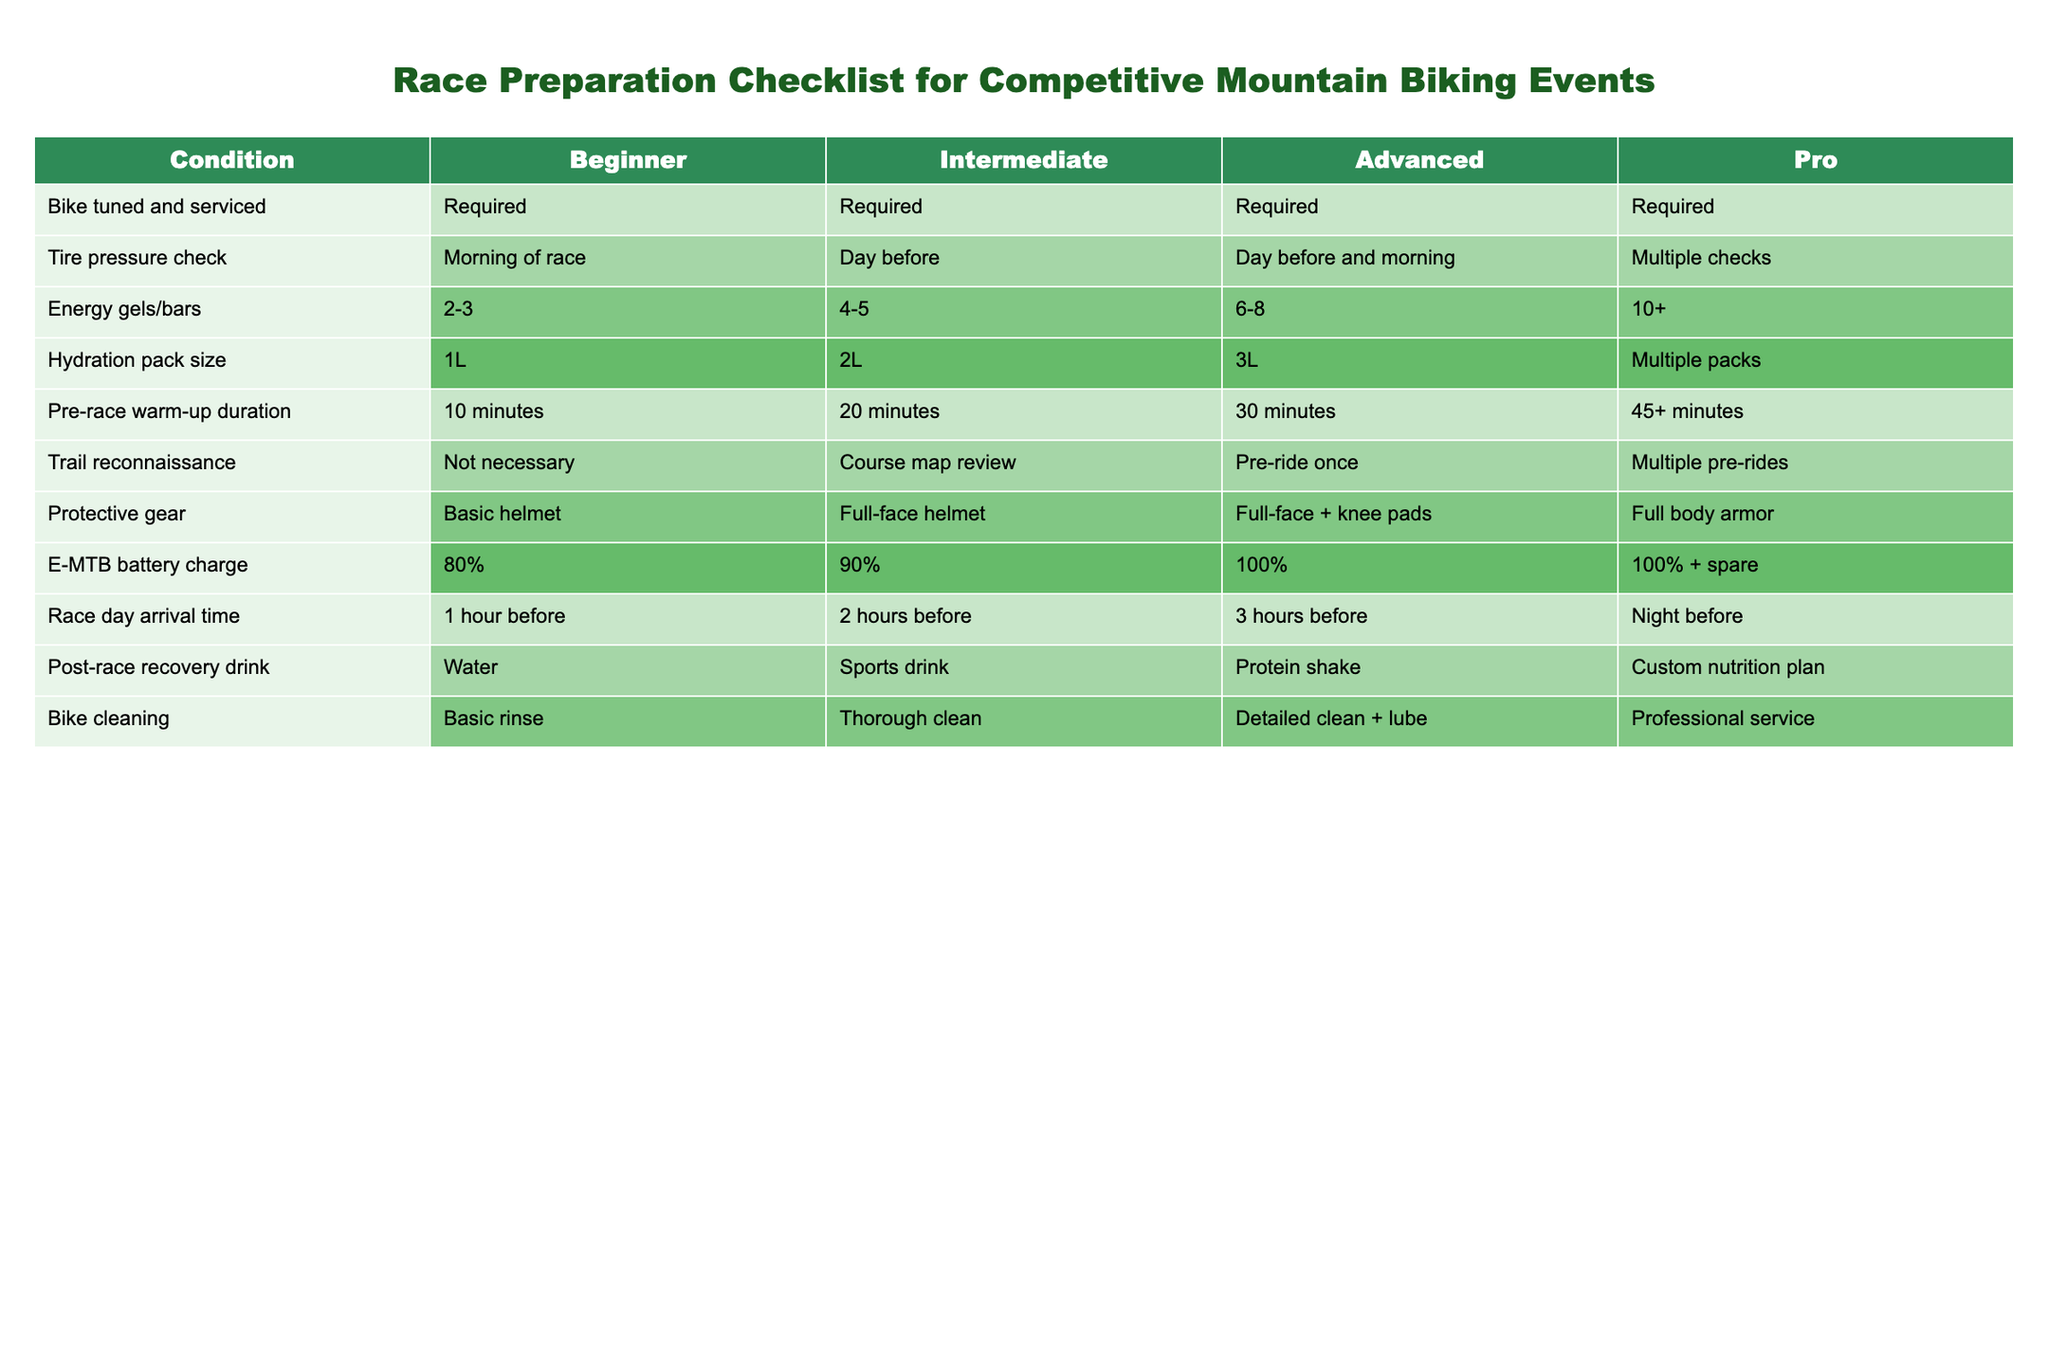What's the required bike service for pros? In the table, all skill levels require their bikes to be tuned and serviced. Thus, for pros, bike tuning and servicing is required as well.
Answer: Required How many energy gels/bars does an advanced racer prepare? According to the table, an advanced racer should prepare 6 to 8 energy gels or bars for the race.
Answer: 6-8 Is a bike cleaning after a race necessary for beginners? The table indicates that beginners perform a basic rinse on their bike, which suggests that cleaning is indeed necessary, though it's minimal.
Answer: Yes How much larger should the hydration pack size be for an intermediate rider compared to a beginner? A beginner needs a 1L hydration pack, while an intermediate rider requires a 2L pack. The difference in size is 2L - 1L = 1L.
Answer: 1L What's the pre-race warm-up duration recommended for intermediate riders? The specified pre-race warm-up duration for intermediate riders in the table is 20 minutes.
Answer: 20 minutes How does the battery charge requirement differ between beginner and advanced riders? A beginner's bike battery should be charged to 80%, while an advanced rider requires a full 100%. The difference in required charge is 100% - 80% = 20%.
Answer: 20% Do all racers require protective gear? The table shows that all levels do require some form of protective gear, though the types vary in complexity from a basic helmet for beginners to full body armor for pros.
Answer: Yes What is the average time for race day arrival across all levels? The arrival times are: 1 hour (beginner), 2 hours (intermediate), 3 hours (advanced), and night before (considered as 12 hours for this calculation). The average is computed as (1 + 2 + 3 + 12) / 4 = 18 / 4 = 4.5 hours.
Answer: 4.5 hours Does an advanced rider have a pre-race reconnaissance requirement? The table indicates that an advanced rider must perform a 'Pre-ride once' for trail reconnaissance, confirming that it is a requirement.
Answer: Yes 